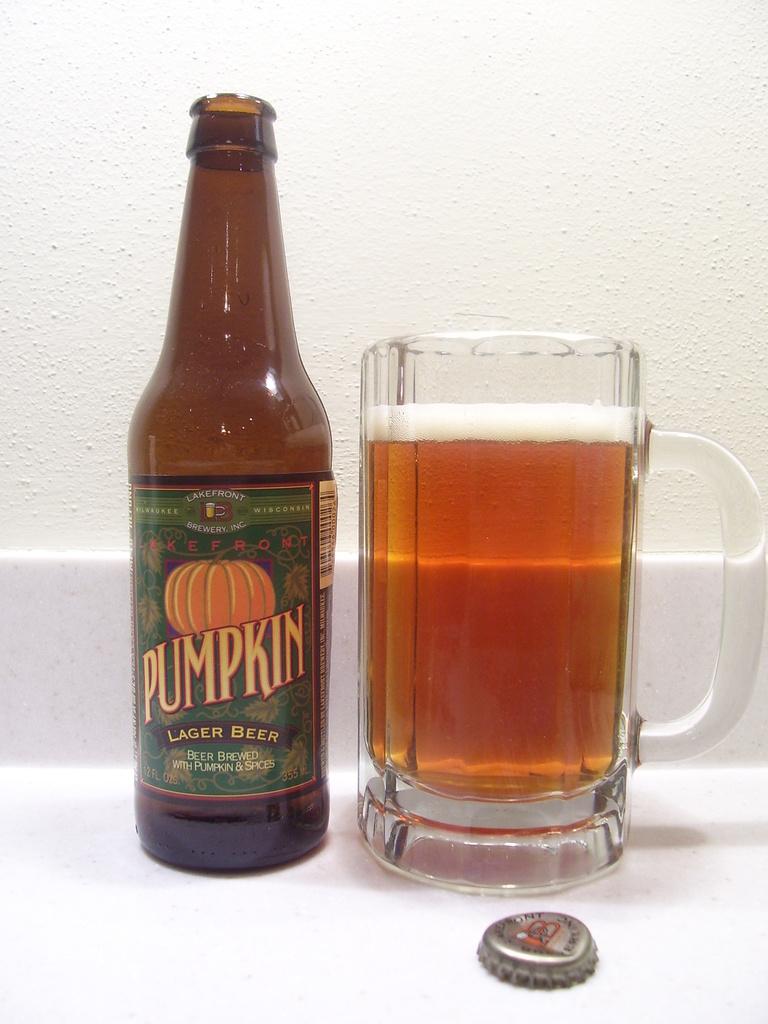What is written on the label under pumpkin?
Your answer should be compact. Lager beer. 